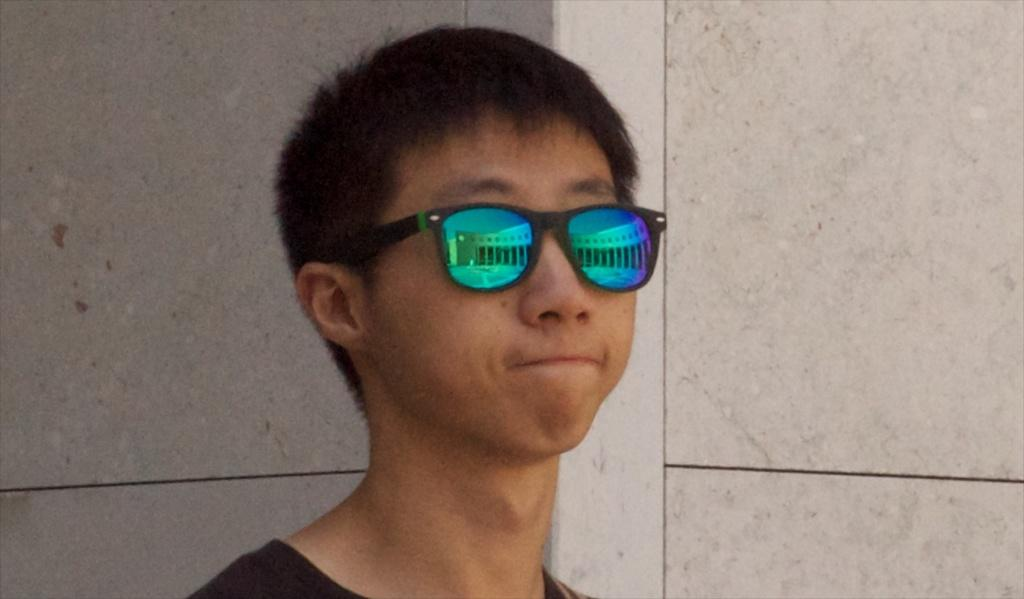Who or what is present in the image? There is a person in the image. What is the person wearing? The person is wearing goggles. What can be seen in the background of the image? There is a wall in the background of the image. What joke is the person telling in the image? There is no indication in the image that the person is telling a joke, so it cannot be determined from the picture. 